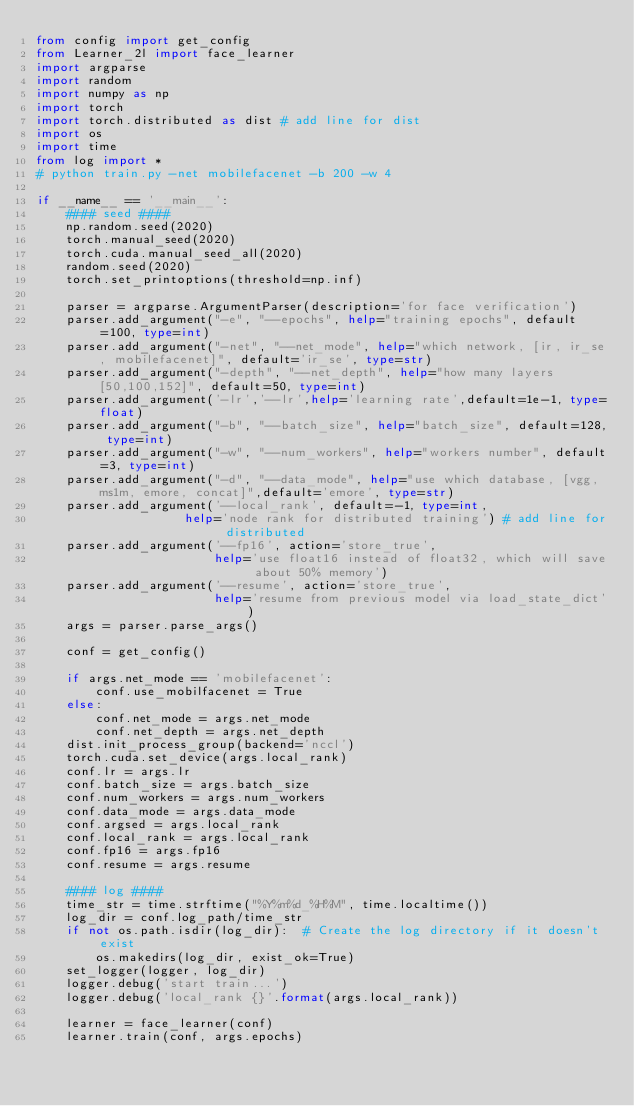<code> <loc_0><loc_0><loc_500><loc_500><_Python_>from config import get_config
from Learner_2l import face_learner
import argparse
import random
import numpy as np
import torch
import torch.distributed as dist # add line for dist
import os
import time
from log import *
# python train.py -net mobilefacenet -b 200 -w 4

if __name__ == '__main__':
    #### seed ####
    np.random.seed(2020)
    torch.manual_seed(2020)
    torch.cuda.manual_seed_all(2020)
    random.seed(2020)
    torch.set_printoptions(threshold=np.inf)

    parser = argparse.ArgumentParser(description='for face verification')
    parser.add_argument("-e", "--epochs", help="training epochs", default=100, type=int)
    parser.add_argument("-net", "--net_mode", help="which network, [ir, ir_se, mobilefacenet]", default='ir_se', type=str)
    parser.add_argument("-depth", "--net_depth", help="how many layers [50,100,152]", default=50, type=int)
    parser.add_argument('-lr','--lr',help='learning rate',default=1e-1, type=float)
    parser.add_argument("-b", "--batch_size", help="batch_size", default=128, type=int)
    parser.add_argument("-w", "--num_workers", help="workers number", default=3, type=int)
    parser.add_argument("-d", "--data_mode", help="use which database, [vgg, ms1m, emore, concat]",default='emore', type=str)
    parser.add_argument('--local_rank', default=-1, type=int,
                    help='node rank for distributed training') # add line for distributed
    parser.add_argument('--fp16', action='store_true',
                        help='use float16 instead of float32, which will save about 50% memory')
    parser.add_argument('--resume', action='store_true',
                        help='resume from previous model via load_state_dict')
    args = parser.parse_args()

    conf = get_config()

    if args.net_mode == 'mobilefacenet':
        conf.use_mobilfacenet = True
    else:
        conf.net_mode = args.net_mode
        conf.net_depth = args.net_depth    
    dist.init_process_group(backend='nccl')
    torch.cuda.set_device(args.local_rank)
    conf.lr = args.lr
    conf.batch_size = args.batch_size
    conf.num_workers = args.num_workers
    conf.data_mode = args.data_mode
    conf.argsed = args.local_rank
    conf.local_rank = args.local_rank
    conf.fp16 = args.fp16
    conf.resume = args.resume

    #### log ####
    time_str = time.strftime("%Y%m%d_%H%M", time.localtime())
    log_dir = conf.log_path/time_str
    if not os.path.isdir(log_dir):  # Create the log directory if it doesn't exist
        os.makedirs(log_dir, exist_ok=True)
    set_logger(logger, log_dir)
    logger.debug('start train...')
    logger.debug('local_rank {}'.format(args.local_rank))

    learner = face_learner(conf)
    learner.train(conf, args.epochs)</code> 